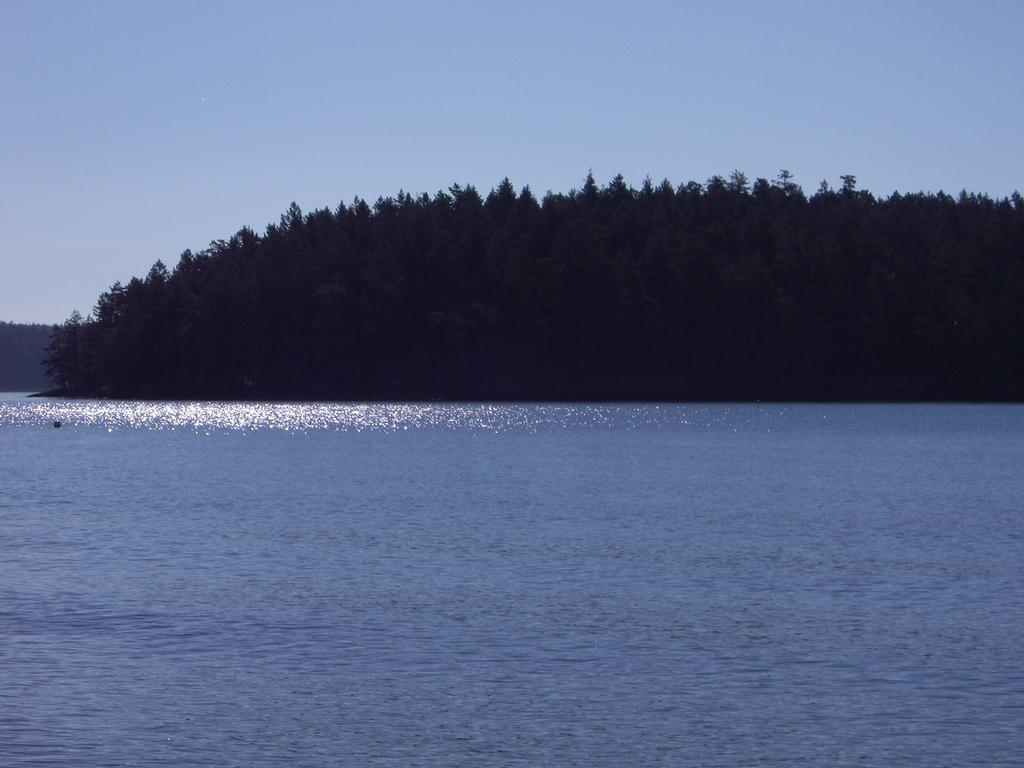What is located in front of the image? There is water in front of the image. What can be seen in the middle of the image? There are multiple trees in the middle of the image. What is visible in the background of the image? The sky is visible in the background of the image. How would you describe the sky in the image? The sky appears to be clear in the image. Can you tell me how many businesses are depicted in the image? There are no businesses present in the image; it features water, trees, and a clear sky. Are there any instances of people kissing in the image? There are no people or any indication of a kiss in the image. 